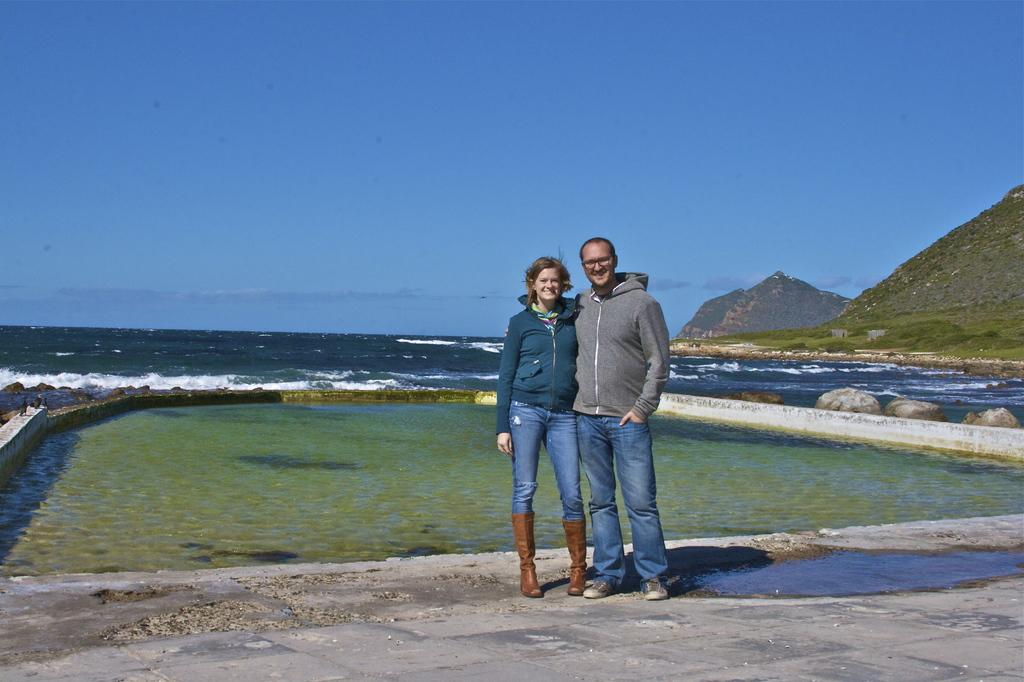How many people are present in the image? There are two people, a man and a woman, present in the image. Where are the man and woman located in the image? Both the man and woman are standing on the road in the image. What can be seen in the background of the image? Water, rocks, hills, and the sky are visible in the background of the image. What is the weather like in the image? The presence of clouds in the sky suggests that it might be partly cloudy. What type of downtown attraction can be seen in the image? There is no downtown or attraction present in the image; it features a man and a woman standing on a road with a natural background. What type of fog is present in the image? There is no fog present in the image; it features a clear sky with clouds. 